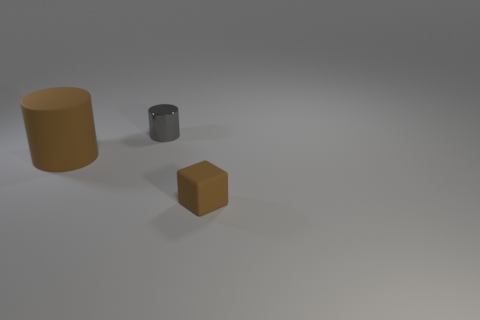What materials are the objects made of in this image? The object on the left resembles a cylinder made of a matte material that could represent something like clay or plastic. The small object in the center appears to be metallic, given its reflective surface and darker color, suggesting it might be made of metal. The cube in the foreground has a surface that seems to mimic the look of rubber, due to its dull finish and the way it absorbs rather than reflects the light. 